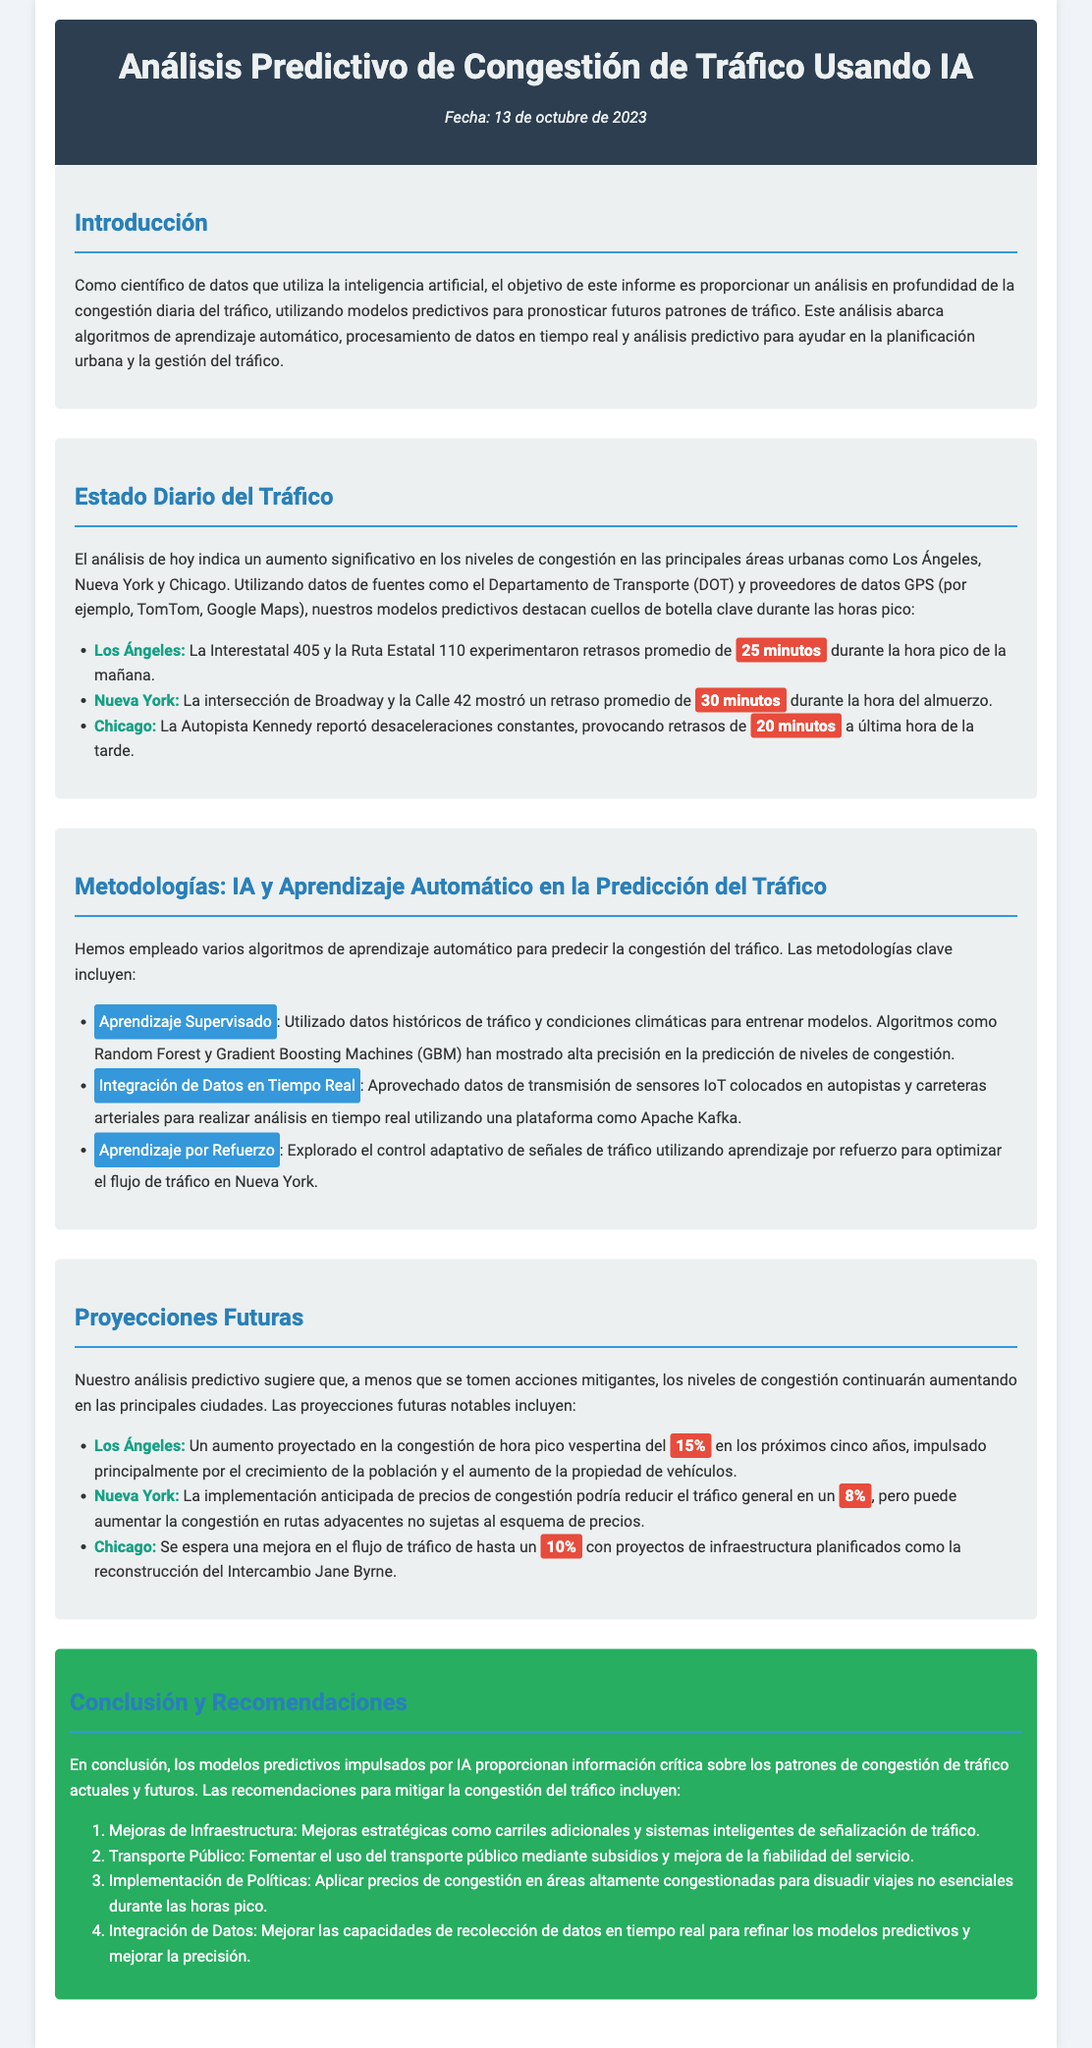¿Cuál es la fecha del informe? La fecha del informe se menciona al principio del documento.
Answer: 13 de octubre de 2023 ¿Qué ciudad experimentó retrasos promedio de 30 minutos durante la hora del almuerzo? El documento proporciona detalles sobre las ciudades y sus correspondientes retrasos.
Answer: Nueva York ¿Cuál es el aumento proyectado en la congestión de Los Ángeles en los próximos cinco años? Se menciona un porcentaje específico relacionado con el aumento de la congestión.
Answer: 15% ¿Qué metodología se utilizó para el análisis en tiempo real del tráfico? Se detallan varios métodos en la sección sobre metodologías del documento.
Answer: Integración de Datos en Tiempo Real ¿Qué mejora se espera en el flujo de tráfico en Chicago con proyectos planificados? Hay una proyección específica sobre la mejora esperada.
Answer: 10% ¿Cuál es una de las recomendaciones para mitigar la congestión del tráfico? Se enumeran varias recomendaciones en la conclusión del informe.
Answer: Mejoras de Infraestructura ¿Qué algoritmo se mencionó como utilizado en el aprendizaje por refuerzo? Se hace referencia a un tipo de aprendizaje específico en la sección de metodologías.
Answer: Aprendizaje por Refuerzo ¿Cuál fue el retraso promedio reportado en la Autopista Kennedy? Se menciona un retraso específico que se produjo en esta autopista.
Answer: 20 minutos 